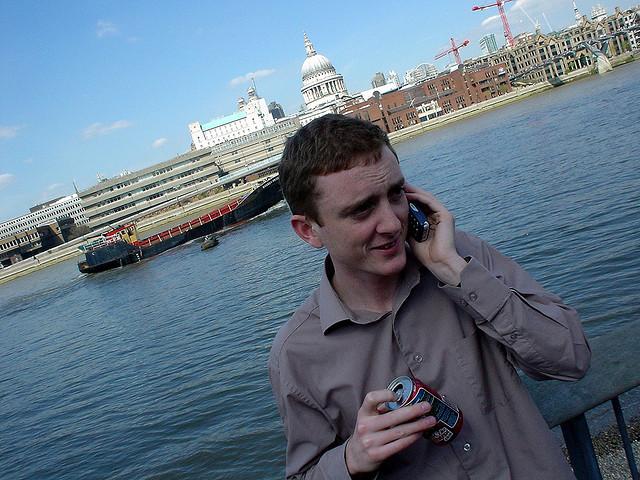Is this in a foreign place?
Answer briefly. No. What is in the man's hand?
Quick response, please. Can. Does the guy have beards?
Answer briefly. No. Does the man need to shave?
Give a very brief answer. No. What is he doing?
Short answer required. Talking on phone. Is he on the Riverside?
Write a very short answer. Yes. Is the boy holding food?
Answer briefly. No. Is the man holding a filet knife?
Quick response, please. No. How many people are in the photo?
Keep it brief. 1. What is the man carrying?
Concise answer only. Can. How many people are pictured?
Answer briefly. 1. What is the man talking to?
Concise answer only. Phone. What kind of glass is the man holding?
Concise answer only. Can. Does this man have on a shirt?
Keep it brief. Yes. Is he wearing glasses?
Short answer required. No. Is this picture in a harbor?
Concise answer only. Yes. 